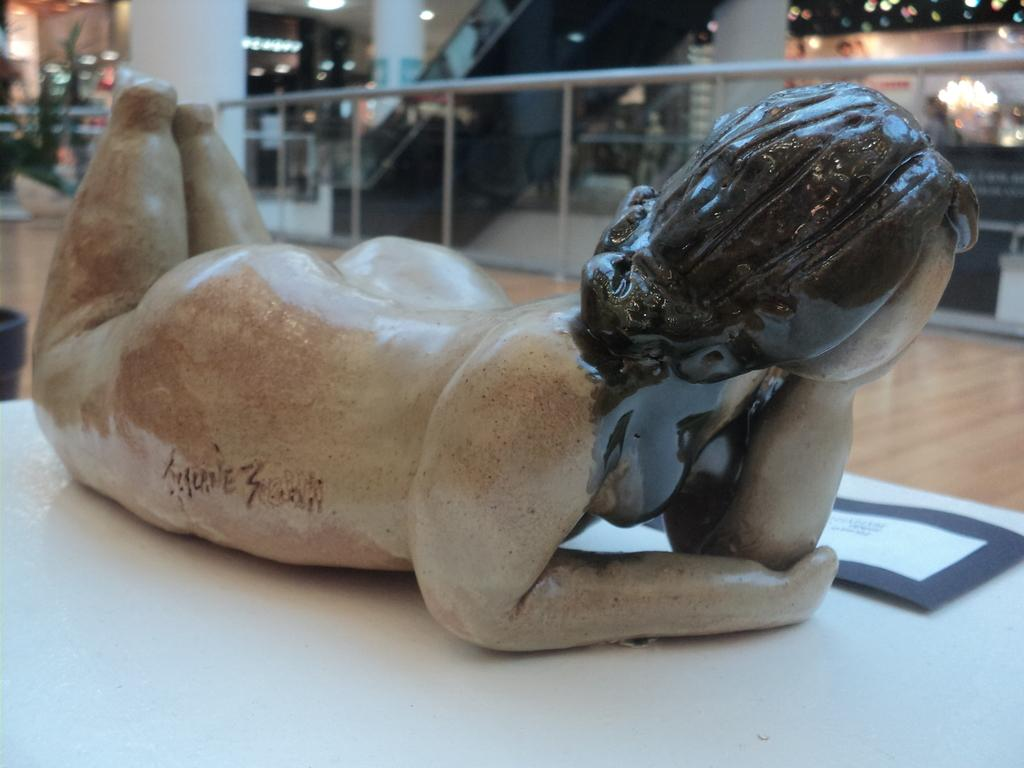What is the main subject in the image? There is a statue in the image. What is placed beside the statue? There is a paper beside the statue. What architectural feature can be seen in the image? There is a railing in the image. What can be seen illuminating the scene? There are lights visible in the image. How would you describe the background of the image? The background of the image is blurry. Reasoning: Let' Let's think step by step in order to produce the conversation. We start by identifying the main subject in the image, which is the statue. Then, we expand the conversation to include other items that are also visible, such as the paper, railing, lights, and the blurry background. Each question is designed to elicit a specific detail about the image that is known from the provided facts. Absurd Question/Answer: What type of corn can be seen growing around the statue in the image? There is no corn present in the image; it features a statue, a paper, a railing, lights, and a blurry background. Can you see a giraffe in the image? No, there is no giraffe present in the image. The image features a statue, a paper, a railing, lights, and a blurry background. 